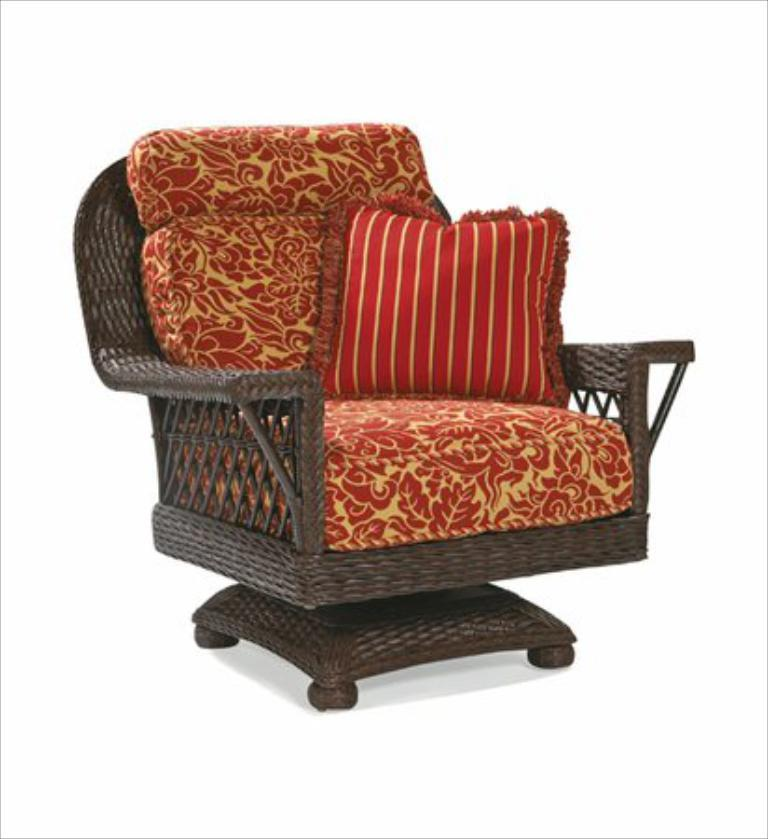What type of furniture is in the image? There is a club chair in the image. What is on the club chair? There is a pillow on the chair. What color is the background of the image? The background of the image is white. How many shoes are visible on the club chair in the image? There are no shoes visible on the club chair in the image. 